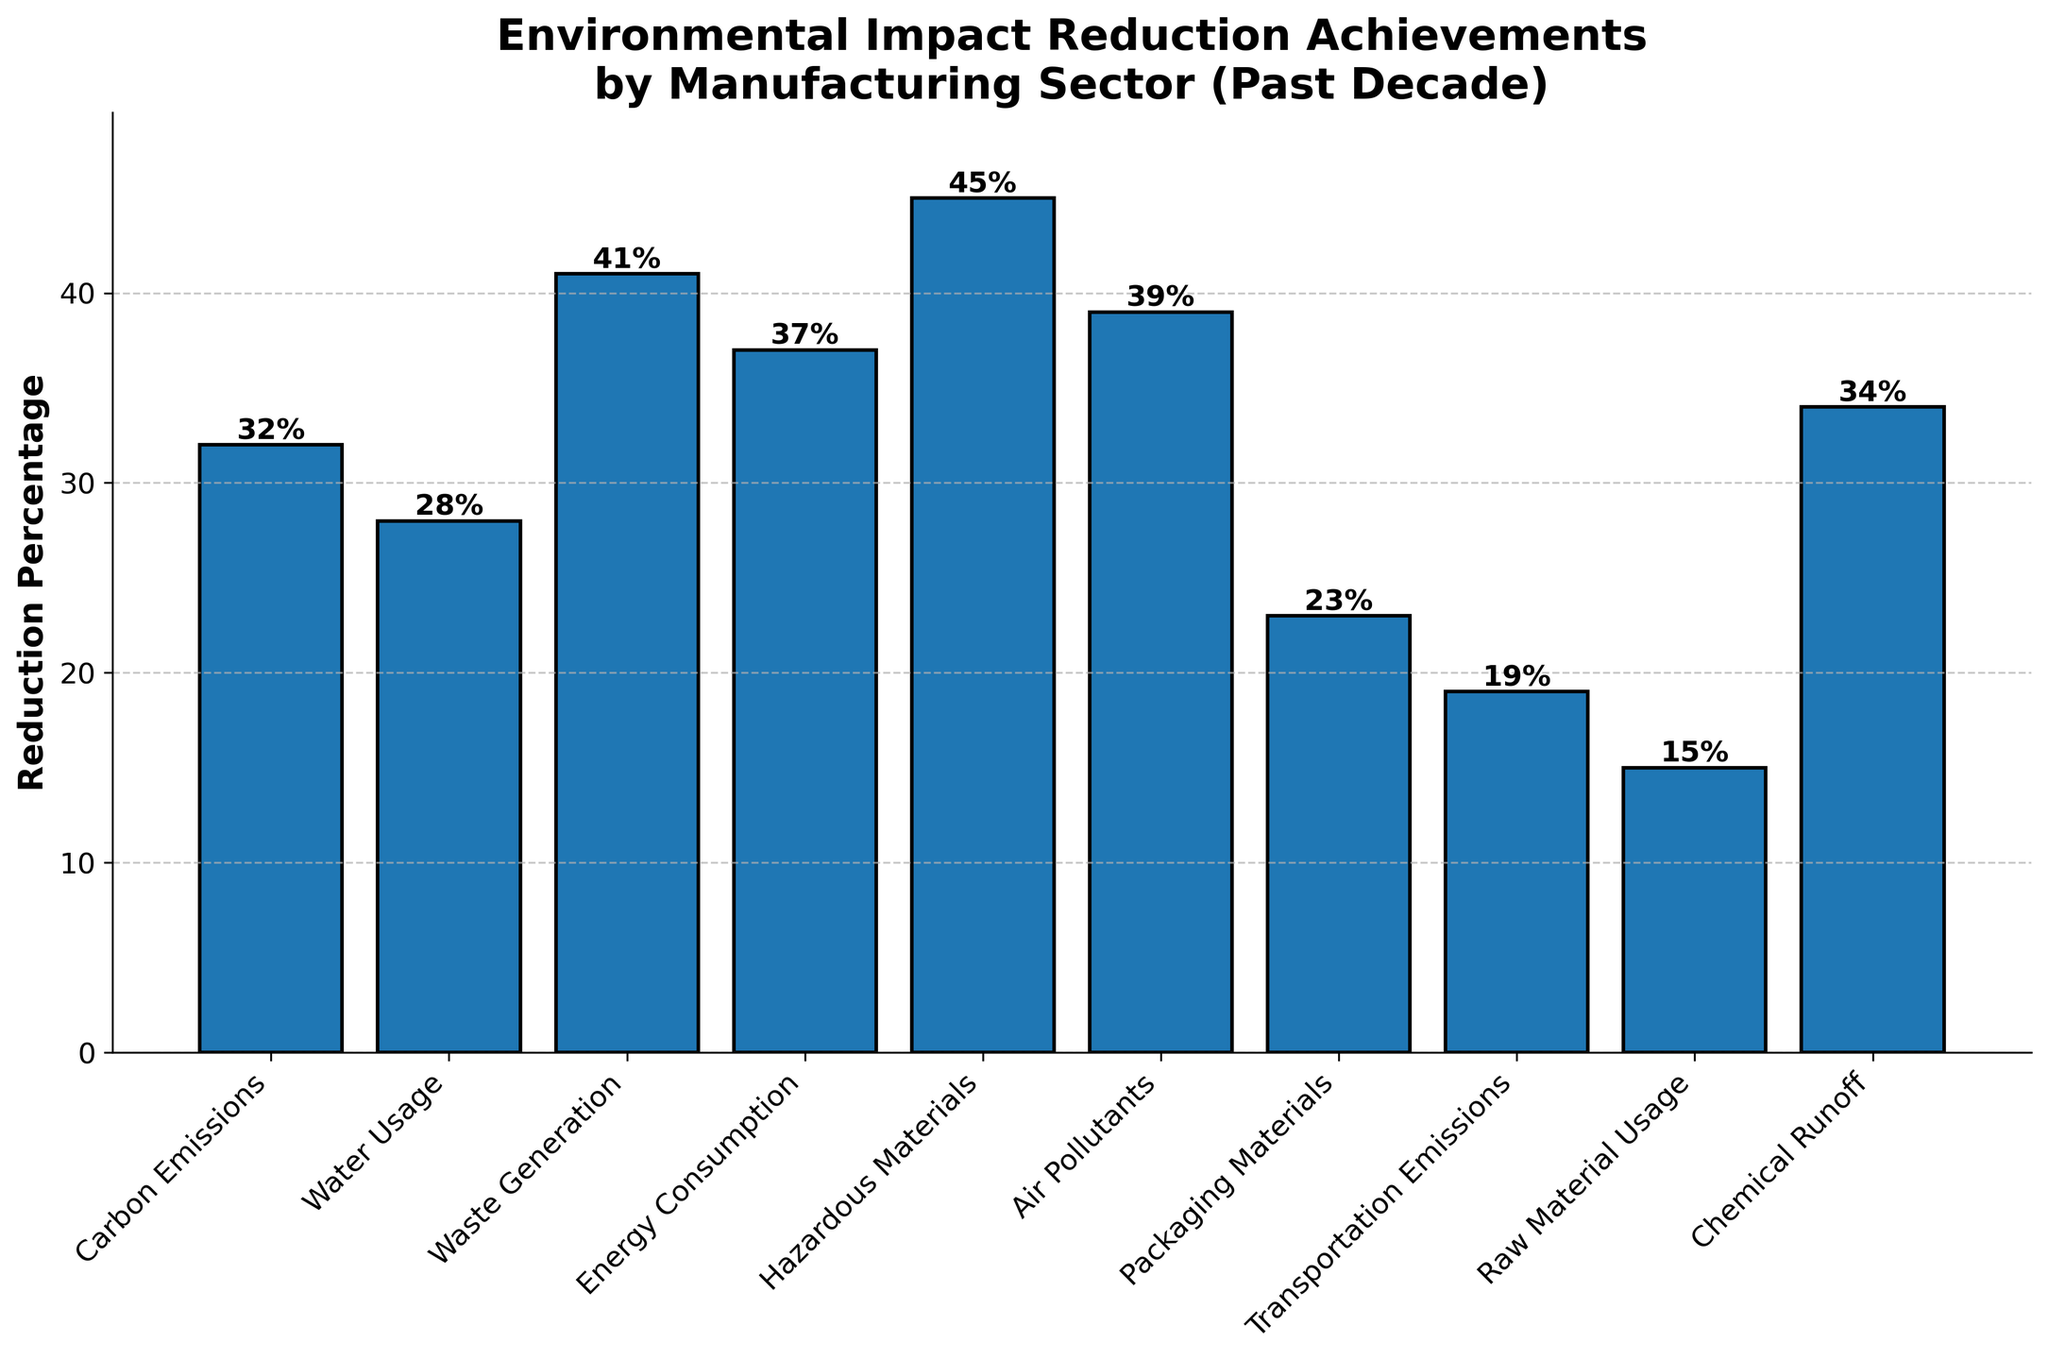Which category has achieved the highest reduction percentage? The figure displays bars representing various categories and their reduction percentages. The tallest bar corresponds to the "Hazardous Materials" category, indicating it has the highest reduction percentage.
Answer: Hazardous Materials What is the total reduction percentage of Carbon Emissions and Chemical Runoff combined? Add the reduction percentages of "Carbon Emissions" (32%) and "Chemical Runoff" (34%). So, 32% + 34% = 66%.
Answer: 66% How much more has Waste Generation been reduced compared to Packaging Materials? Find the reduction percentage of "Waste Generation" (41%) and "Packaging Materials" (23%), then calculate the difference, 41% - 23% = 18%.
Answer: 18% What is the average reduction percentage across all categories? Add up all the reduction percentages and divide by the number of categories: (32 + 28 + 41 + 37 + 45 + 39 + 23 + 19 + 15 + 34) / 10 = 313 / 10 = 31.3%.
Answer: 31.3% Which two categories have the closest reduction percentages? Compare the reduction percentages of all categories to find the smallest difference. The closest values are "Water Usage" (28%) and "Chemical Runoff" (34%), with a difference of 34% - 28% = 6%.
Answer: Water Usage and Chemical Runoff If you add the reduction percentages of the three categories with the lowest values, what is the sum? Identify the three lowest values: Raw Material Usage (15%), Transportation Emissions (19%), and Packaging Materials (23%). Sum them up: 15% + 19% + 23% = 57%.
Answer: 57% By how much does Energy Consumption's reduction percentage exceed the average across all categories? First, find the average percentage (31.3%). Then find Energy Consumption's percentage (37%) and subtract the average: 37% - 31.3% = 5.7%.
Answer: 5.7% List the categories with a reduction percentage greater than 35%. Identify all bars exceeding 35%: Carbon Emissions (32%) is not included, while Energy Consumption (37%), Hazardous Materials (45%), Waste Generation (41%), Air Pollutants (39%), and Chemical Runoff (34%) exceed 35%.
Answer: Energy Consumption, Hazardous Materials, Waste Generation, Air Pollutants How do the reduction percentages of Air Pollutants and Water Usage compare? Identify their percentages: Air Pollutants (39%) and Water Usage (28%). Air Pollutants have a higher reduction by 39% - 28% = 11%.
Answer: Air Pollutants are 11% higher Verify if the reduction percentage in Raw Material Usage is less than half the reduction in Hazardous Materials. Calculate half of Hazardous Materials reduction (45% / 2 = 22.5%) and compare it to Raw Material Usage (15%). Since 15% is less than 22.5%, the statement is true.
Answer: True 